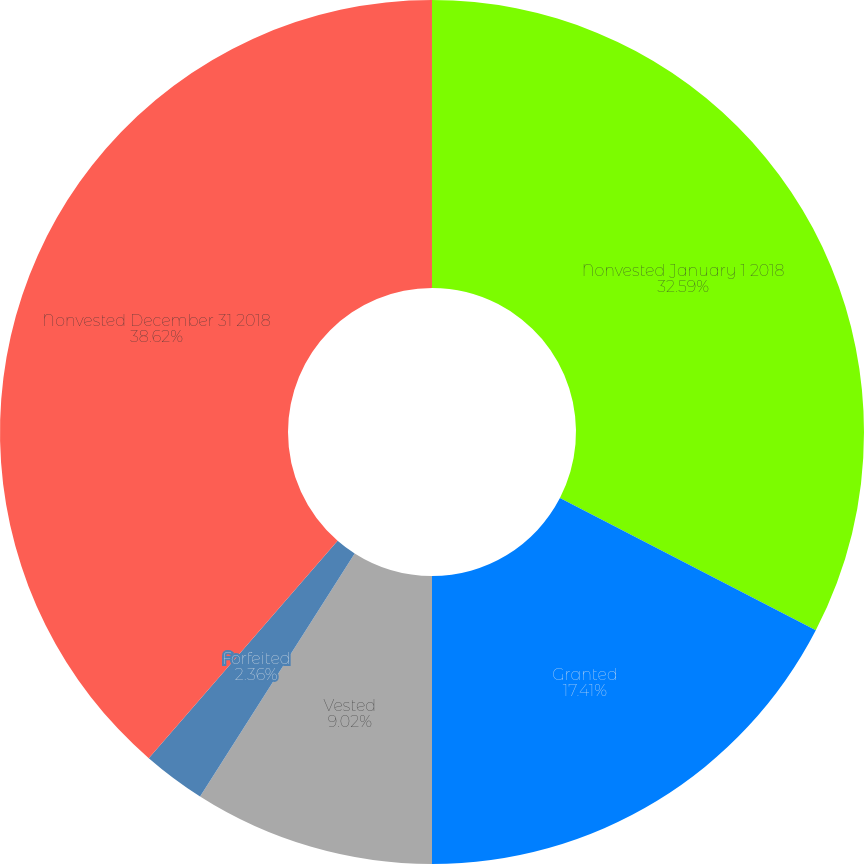<chart> <loc_0><loc_0><loc_500><loc_500><pie_chart><fcel>Nonvested January 1 2018<fcel>Granted<fcel>Vested<fcel>Forfeited<fcel>Nonvested December 31 2018<nl><fcel>32.59%<fcel>17.41%<fcel>9.02%<fcel>2.36%<fcel>38.62%<nl></chart> 